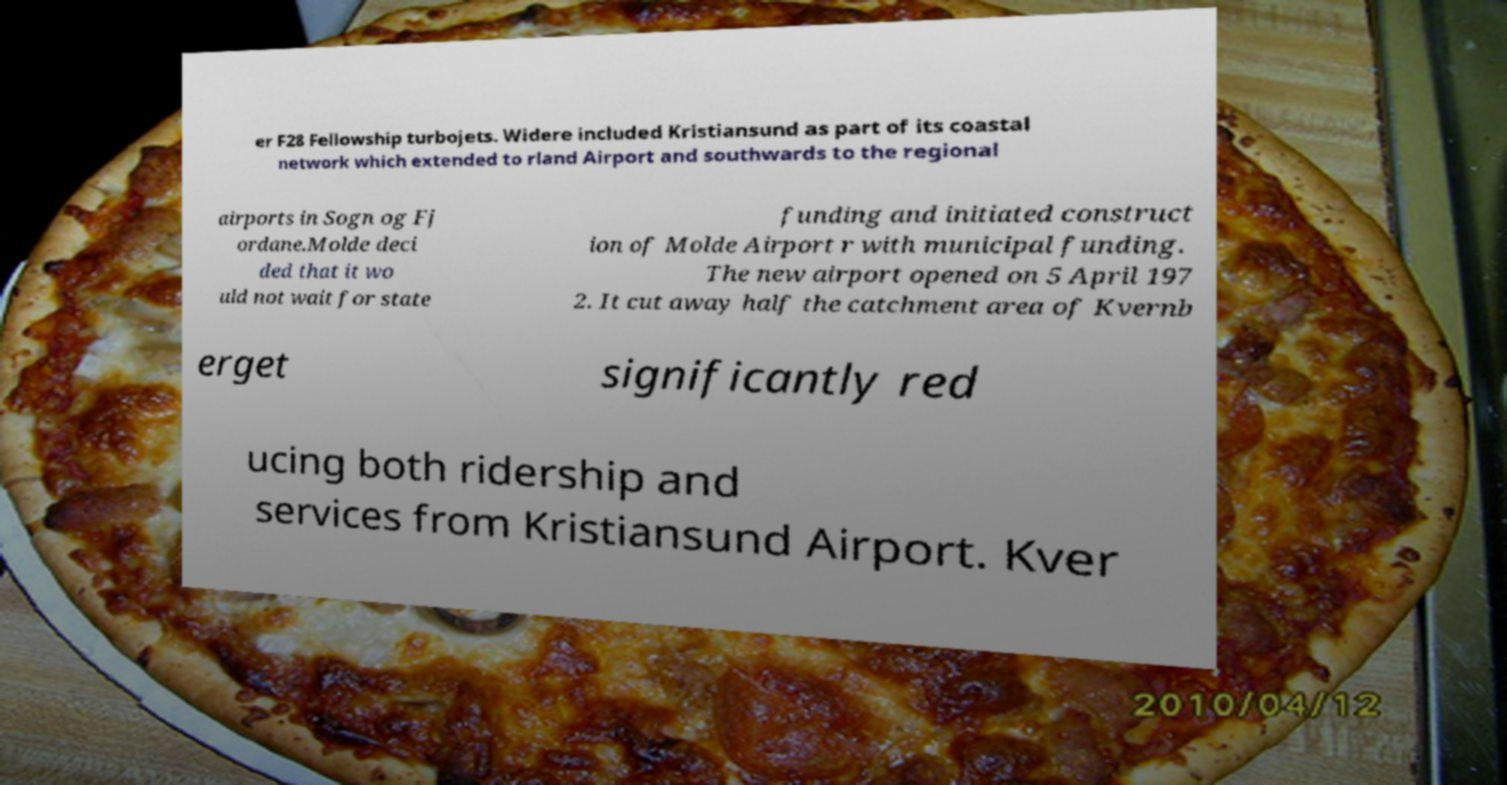Could you extract and type out the text from this image? er F28 Fellowship turbojets. Widere included Kristiansund as part of its coastal network which extended to rland Airport and southwards to the regional airports in Sogn og Fj ordane.Molde deci ded that it wo uld not wait for state funding and initiated construct ion of Molde Airport r with municipal funding. The new airport opened on 5 April 197 2. It cut away half the catchment area of Kvernb erget significantly red ucing both ridership and services from Kristiansund Airport. Kver 